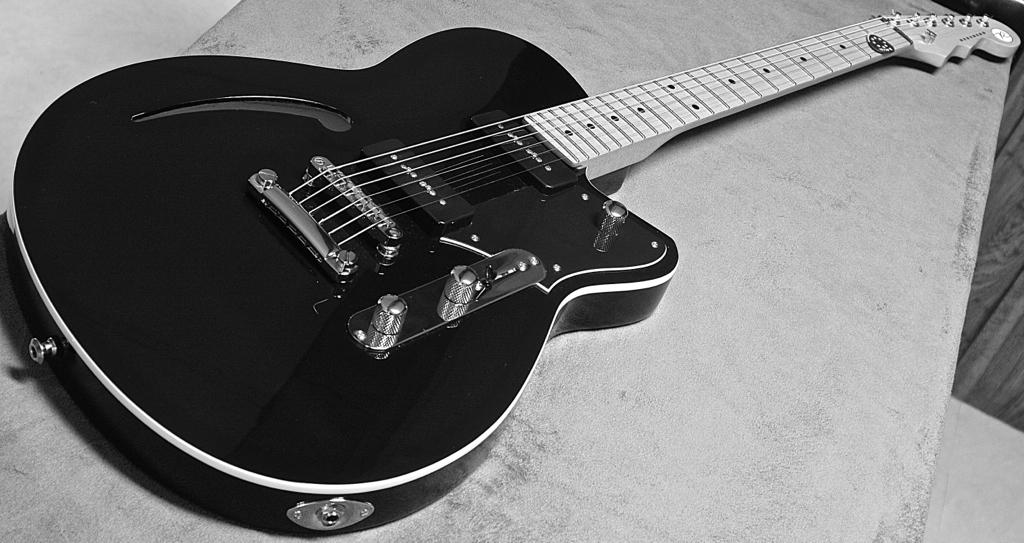What type of picture is in the image? There is a black and white picture in the image. What object is also visible in the image? There is a guitar in the image. Where is the guitar placed? The guitar is kept on a table. What type of belief is depicted in the image? There is no belief depicted in the image; it features a black and white picture and a guitar. What can be used to hold a liquid in the image? There is no can present in the image. 